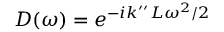<formula> <loc_0><loc_0><loc_500><loc_500>D ( \omega ) = e ^ { - i k ^ { \prime \prime } L \omega ^ { 2 } / 2 }</formula> 